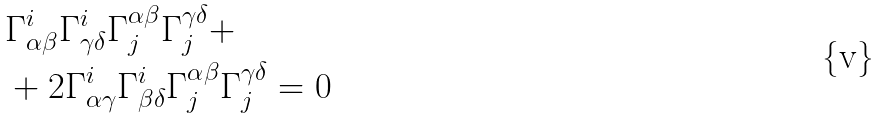Convert formula to latex. <formula><loc_0><loc_0><loc_500><loc_500>& \Gamma _ { \alpha \beta } ^ { i } \Gamma _ { \gamma \delta } ^ { i } \Gamma ^ { \alpha \beta } _ { j } \Gamma ^ { \gamma \delta } _ { j } + \\ & + 2 \Gamma _ { \alpha \gamma } ^ { i } \Gamma _ { \beta \delta } ^ { i } \Gamma ^ { \alpha \beta } _ { j } \Gamma ^ { \gamma \delta } _ { j } = 0</formula> 